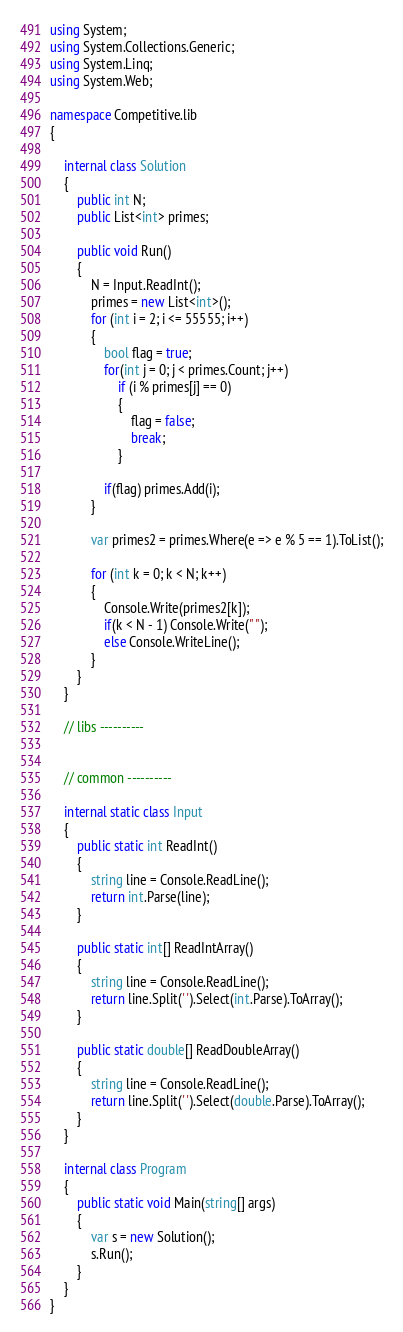Convert code to text. <code><loc_0><loc_0><loc_500><loc_500><_C#_>using System;
using System.Collections.Generic;
using System.Linq;
using System.Web;

namespace Competitive.lib
{

    internal class Solution
    {
        public int N;
        public List<int> primes;

        public void Run()
        {
            N = Input.ReadInt();
            primes = new List<int>();
            for (int i = 2; i <= 55555; i++)
            {
                bool flag = true;
                for(int j = 0; j < primes.Count; j++)
                    if (i % primes[j] == 0)
                    {
                        flag = false;
                        break;
                    }

                if(flag) primes.Add(i);
            }

            var primes2 = primes.Where(e => e % 5 == 1).ToList();

            for (int k = 0; k < N; k++)
            {
                Console.Write(primes2[k]);
                if(k < N - 1) Console.Write(" ");
                else Console.WriteLine();
            }
        }
    }

    // libs ----------


    // common ----------

    internal static class Input
    {
        public static int ReadInt()
        {
            string line = Console.ReadLine();
            return int.Parse(line);
        }

        public static int[] ReadIntArray()
        {
            string line = Console.ReadLine();
            return line.Split(' ').Select(int.Parse).ToArray();
        }

        public static double[] ReadDoubleArray()
        {
            string line = Console.ReadLine();
            return line.Split(' ').Select(double.Parse).ToArray();
        }
    }

    internal class Program
    {
        public static void Main(string[] args)
        {
            var s = new Solution();
            s.Run();
        }
    }
}</code> 